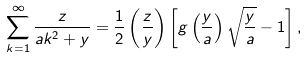Convert formula to latex. <formula><loc_0><loc_0><loc_500><loc_500>\sum _ { k = 1 } ^ { \infty } \frac { z } { a k ^ { 2 } + y } = \frac { 1 } { 2 } \left ( \frac { z } { y } \right ) \left [ g \left ( \frac { y } { a } \right ) \sqrt { \frac { y } { a } } - 1 \right ] ,</formula> 